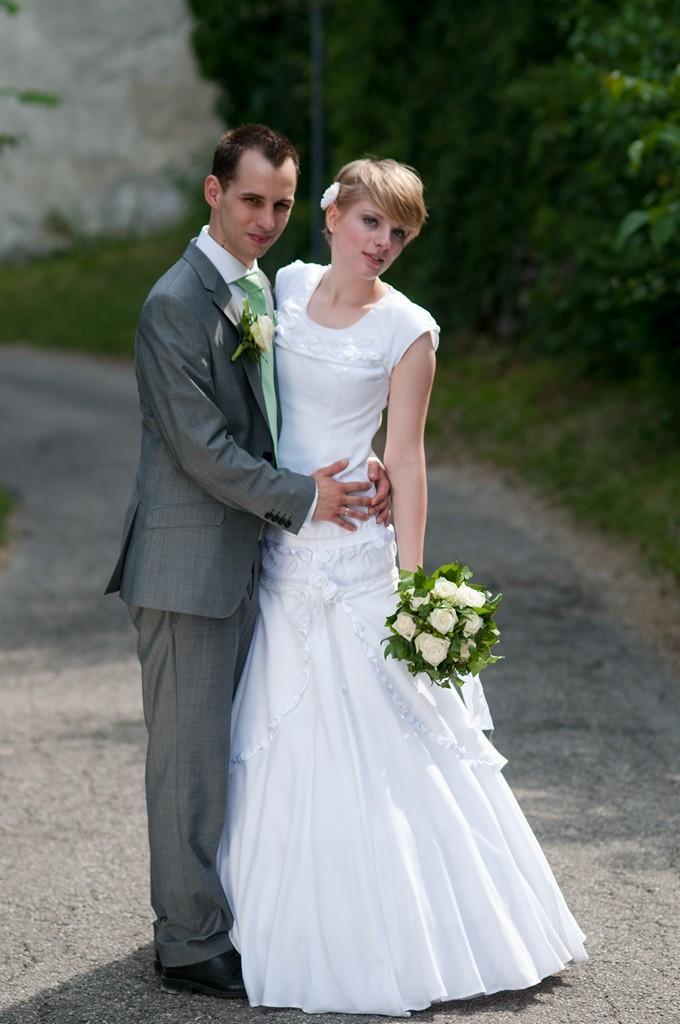In one or two sentences, can you explain what this image depicts? In this picture there is a couple standing and there is a person standing in the right corner is holding a bouquet in her hand and there are trees in the background. 